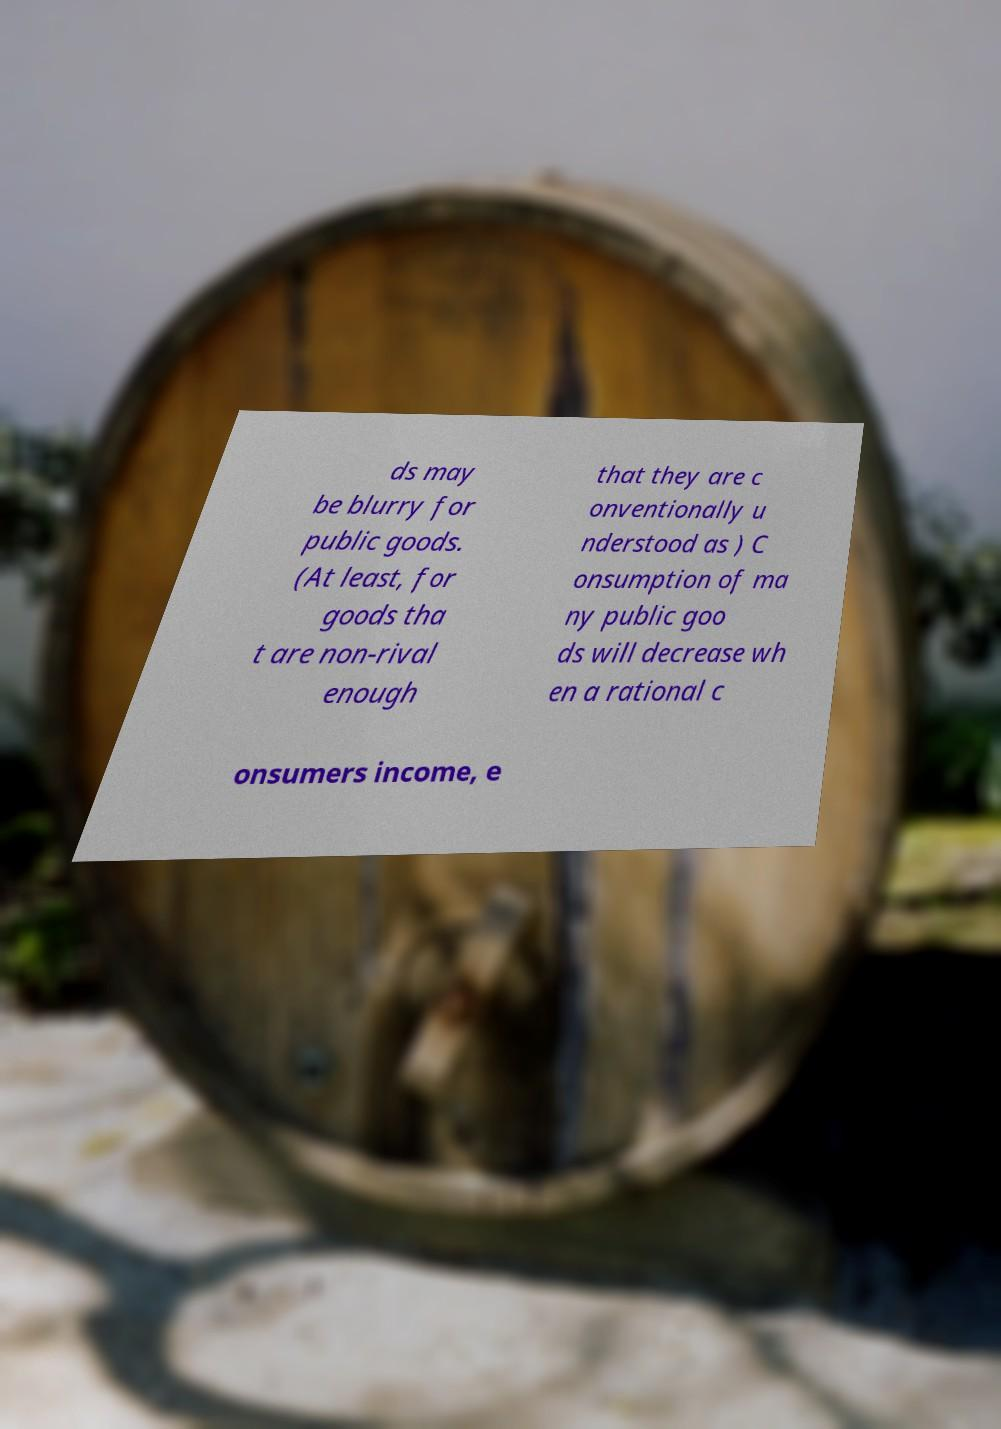For documentation purposes, I need the text within this image transcribed. Could you provide that? ds may be blurry for public goods. (At least, for goods tha t are non-rival enough that they are c onventionally u nderstood as ) C onsumption of ma ny public goo ds will decrease wh en a rational c onsumers income, e 